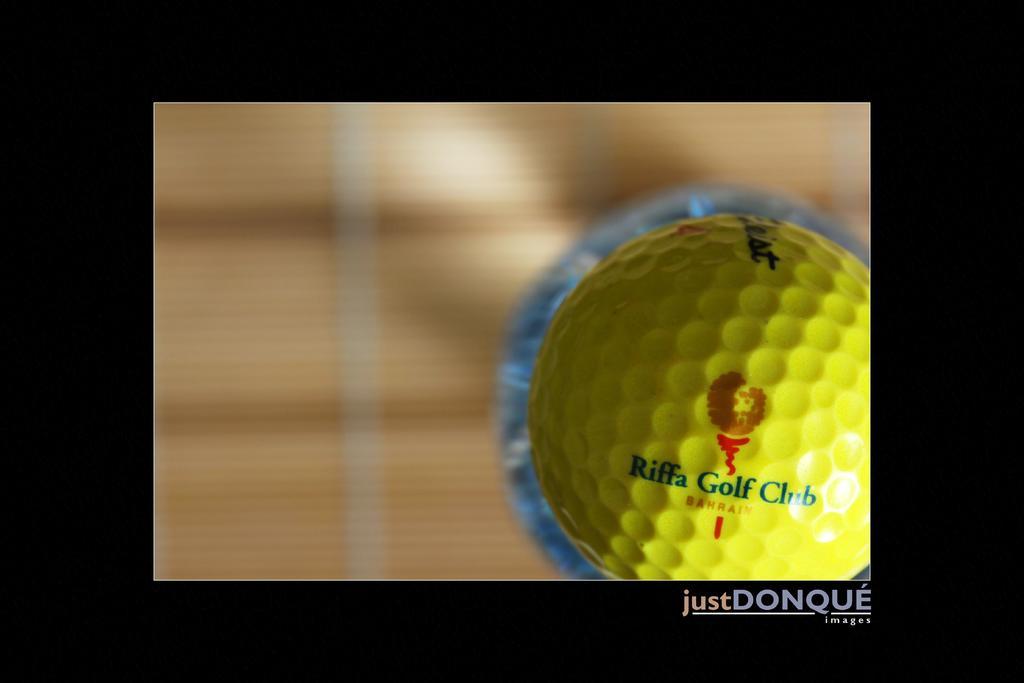Describe this image in one or two sentences. In this image I can see the golf ball in yellow color and I can see the blurred background. 